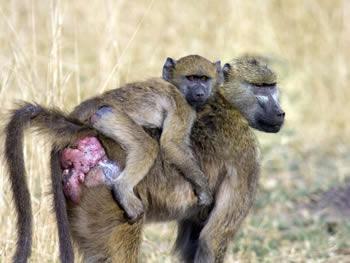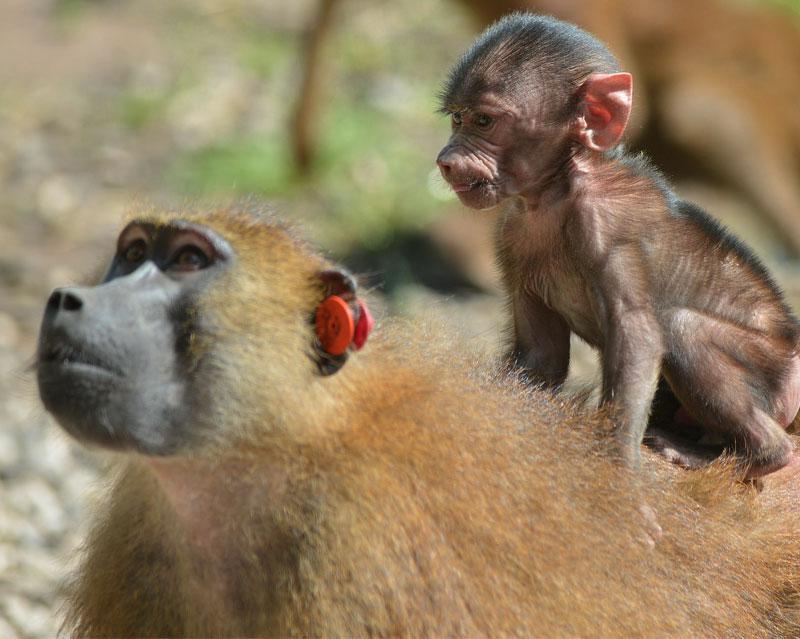The first image is the image on the left, the second image is the image on the right. Given the left and right images, does the statement "One image depicts at aleast a dozen baboons posed on a dry surface." hold true? Answer yes or no. No. The first image is the image on the left, the second image is the image on the right. Analyze the images presented: Is the assertion "There is exactly one animal in one of the images." valid? Answer yes or no. No. The first image is the image on the left, the second image is the image on the right. Considering the images on both sides, is "An image shows the bulbous pinkish rear of one adult baboon." valid? Answer yes or no. Yes. The first image is the image on the left, the second image is the image on the right. Analyze the images presented: Is the assertion "There is a single babboon in one of the images." valid? Answer yes or no. No. 